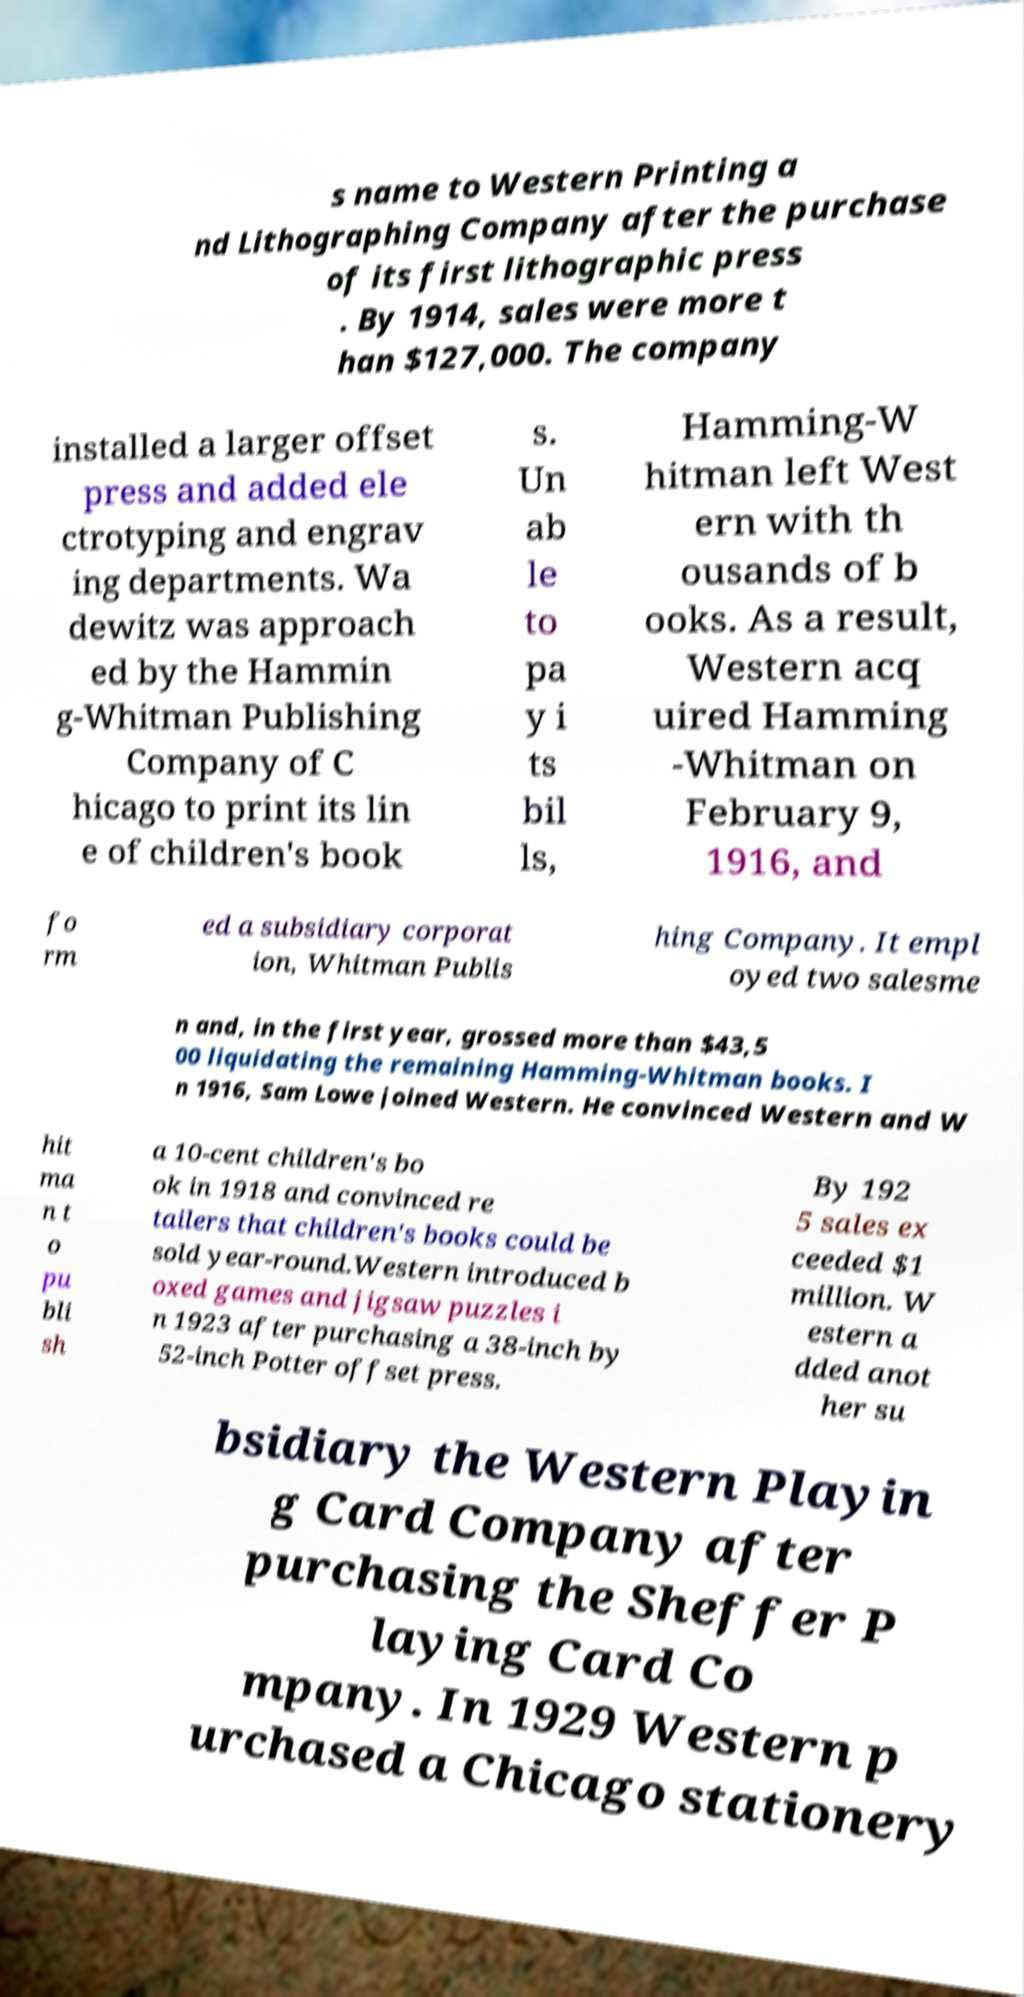For documentation purposes, I need the text within this image transcribed. Could you provide that? s name to Western Printing a nd Lithographing Company after the purchase of its first lithographic press . By 1914, sales were more t han $127,000. The company installed a larger offset press and added ele ctrotyping and engrav ing departments. Wa dewitz was approach ed by the Hammin g-Whitman Publishing Company of C hicago to print its lin e of children's book s. Un ab le to pa y i ts bil ls, Hamming-W hitman left West ern with th ousands of b ooks. As a result, Western acq uired Hamming -Whitman on February 9, 1916, and fo rm ed a subsidiary corporat ion, Whitman Publis hing Company. It empl oyed two salesme n and, in the first year, grossed more than $43,5 00 liquidating the remaining Hamming-Whitman books. I n 1916, Sam Lowe joined Western. He convinced Western and W hit ma n t o pu bli sh a 10-cent children's bo ok in 1918 and convinced re tailers that children's books could be sold year-round.Western introduced b oxed games and jigsaw puzzles i n 1923 after purchasing a 38-inch by 52-inch Potter offset press. By 192 5 sales ex ceeded $1 million. W estern a dded anot her su bsidiary the Western Playin g Card Company after purchasing the Sheffer P laying Card Co mpany. In 1929 Western p urchased a Chicago stationery 